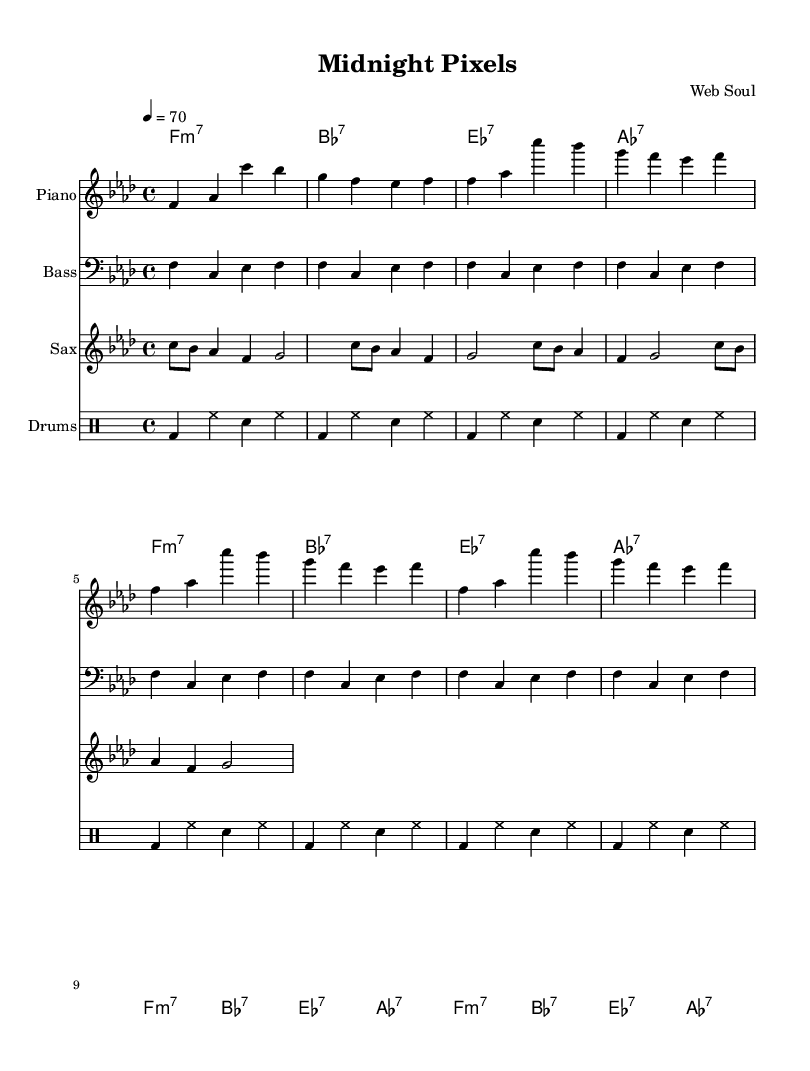What is the key signature of this music? The key signature is indicated at the beginning of the staff. In this case, it consists of four flats, which signify F minor.
Answer: F minor What is the time signature of this music? The time signature is located at the beginning of the score, indicated by the fraction 4/4. This means there are four beats per measure and the quarter note gets one beat.
Answer: 4/4 What is the tempo marking of this score? The tempo marking is usually found at the start of the score, indicated by "4 = 70". This means that there are 70 beats per minute played at a moderate pace.
Answer: 70 How many measures are repeated in the piano part? The piano part shows a repeated section that unfolds three times, indicating that these measures will be played three times before moving on.
Answer: 3 What are the chord names in the progression? The chords are listed in the chord names section and include F minor 7, B flat 7, E flat 7, and A flat 7, which are played throughout the song.
Answer: F minor 7, B flat 7, E flat 7, A flat 7 What is the main melodic instrument in this arrangement? The main melodic instrument is identified on its staff and is composed primarily for the saxophone, as it plays the most prominent melodic line.
Answer: Saxophone Which rhythmic pattern is used in the drums? The drumming part shows a consistent pattern that includes bass drums, hi-hats, and snare hits, specifically representing a repeating sequence throughout the score.
Answer: Bass, hi-hat, snare 